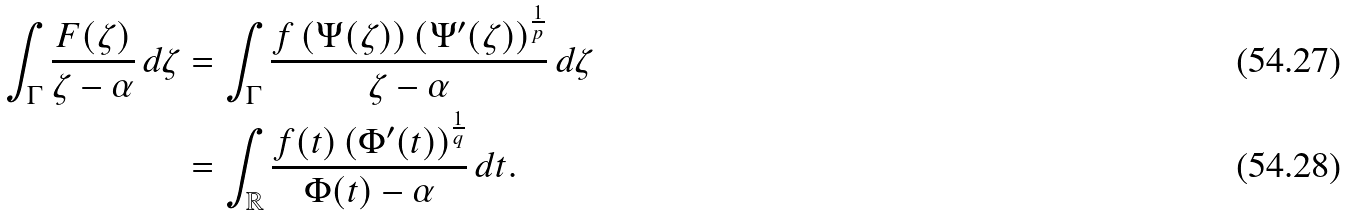Convert formula to latex. <formula><loc_0><loc_0><loc_500><loc_500>\int _ { \Gamma } \frac { F ( \zeta ) } { \zeta - \alpha } \, d \zeta & = \int _ { \Gamma } \frac { f \left ( \Psi ( \zeta ) \right ) \left ( \Psi ^ { \prime } ( \zeta ) \right ) ^ { \frac { 1 } { p } } } { \zeta - \alpha } \, d \zeta \\ & = \int _ { \mathbb { R } } \frac { f ( t ) \left ( \Phi ^ { \prime } ( t ) \right ) ^ { \frac { 1 } { q } } } { \Phi ( t ) - \alpha } \, d t .</formula> 